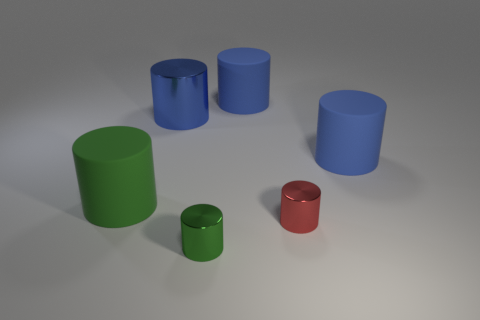There is a green shiny object; is its shape the same as the blue rubber object behind the large blue shiny object?
Make the answer very short. Yes. Are there any other things that have the same color as the big shiny thing?
Your response must be concise. Yes. Do the green matte object and the red cylinder have the same size?
Provide a succinct answer. No. The big green cylinder to the left of the rubber cylinder that is behind the large blue matte thing in front of the big blue shiny cylinder is made of what material?
Offer a very short reply. Rubber. Are there an equal number of big green rubber things that are in front of the red metallic cylinder and yellow shiny spheres?
Your answer should be very brief. Yes. What number of things are either red cylinders or large blue matte objects?
Your answer should be very brief. 3. What is the shape of the blue thing that is the same material as the tiny red thing?
Ensure brevity in your answer.  Cylinder. There is a red object on the right side of the small cylinder in front of the red metallic cylinder; what is its size?
Make the answer very short. Small. What number of big objects are either green cylinders or blue rubber objects?
Provide a succinct answer. 3. How many other things are the same color as the large metallic thing?
Give a very brief answer. 2. 